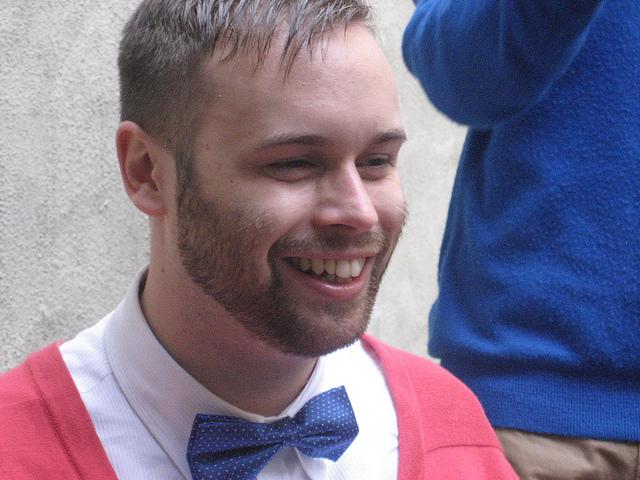Is this man happy?
Quick response, please. Yes. Is this man angry?
Write a very short answer. No. What accessory is the man wearing?
Short answer required. Bowtie. 